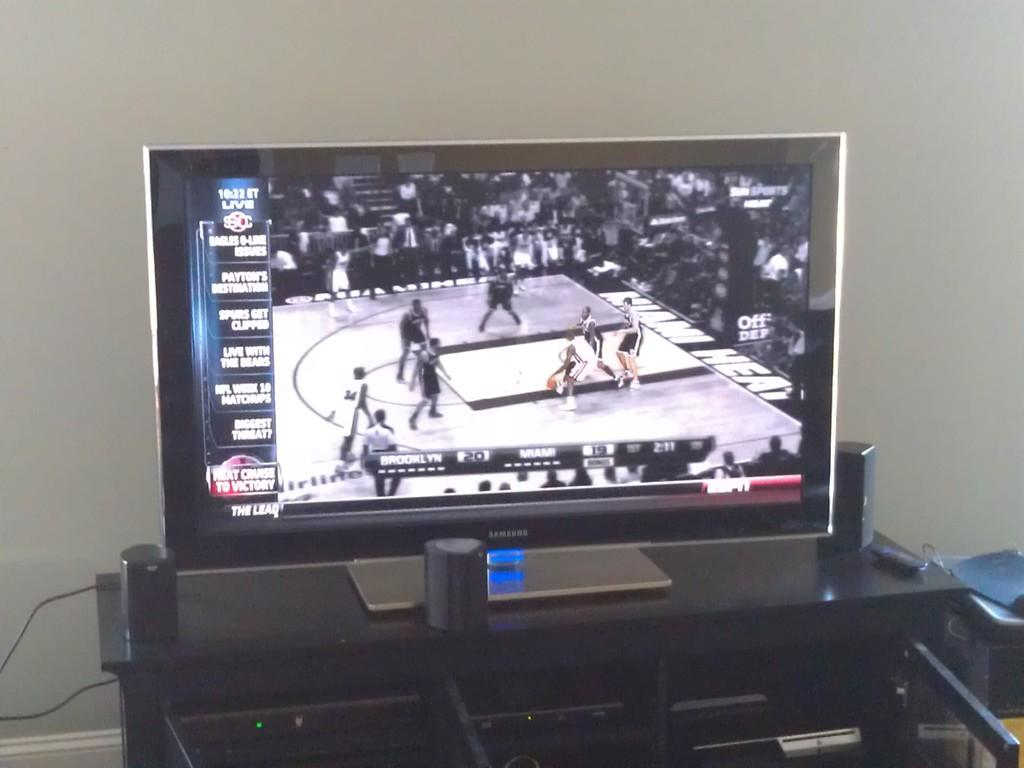<image>
Share a concise interpretation of the image provided. A basketball game is being watched on a Samsung tv. 